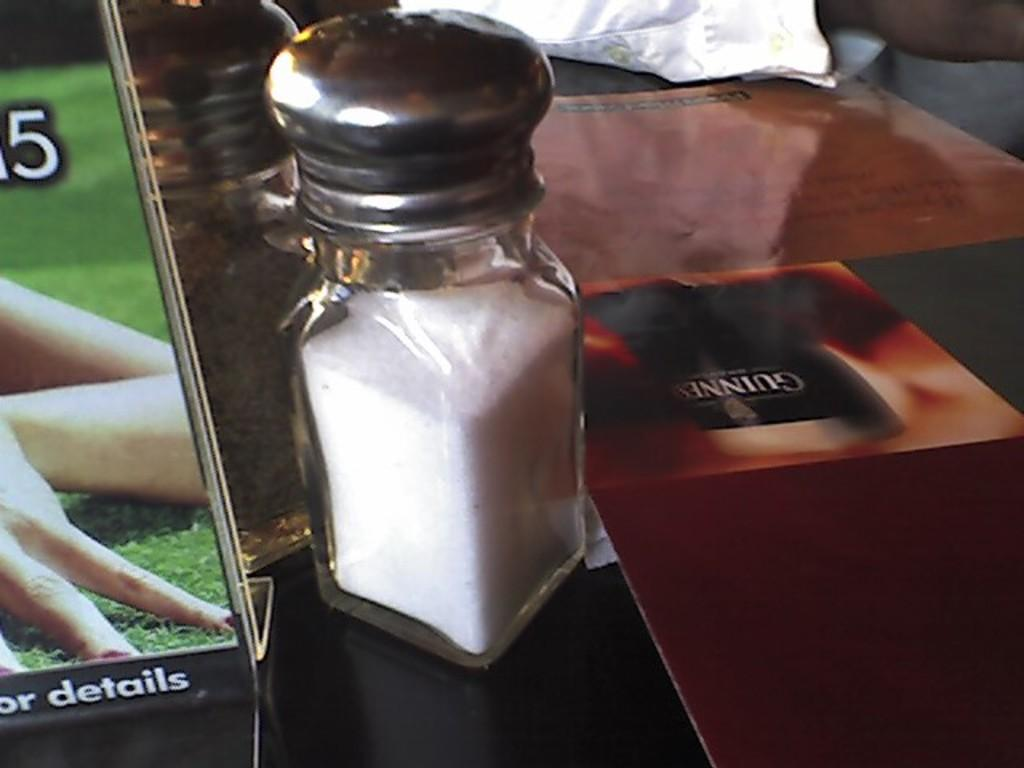What type of containers are visible in the image? There are jars in the image. What other object can be seen in the image? There is a board in the image. What is the board likely used for? The board might be used for displaying or organizing the objects on the platform. What is the platform holding in the image? There are objects on a platform in the image. What type of house is visible in the image? There is no house present in the image. What ornament is hanging from the ceiling in the image? There is no ornament hanging from the ceiling in the image. 